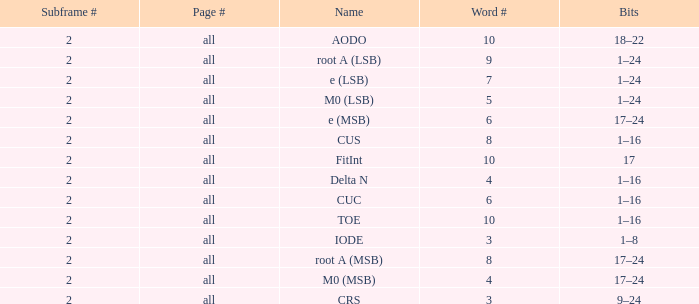What is the total subframe count with Bits of 18–22? 2.0. 